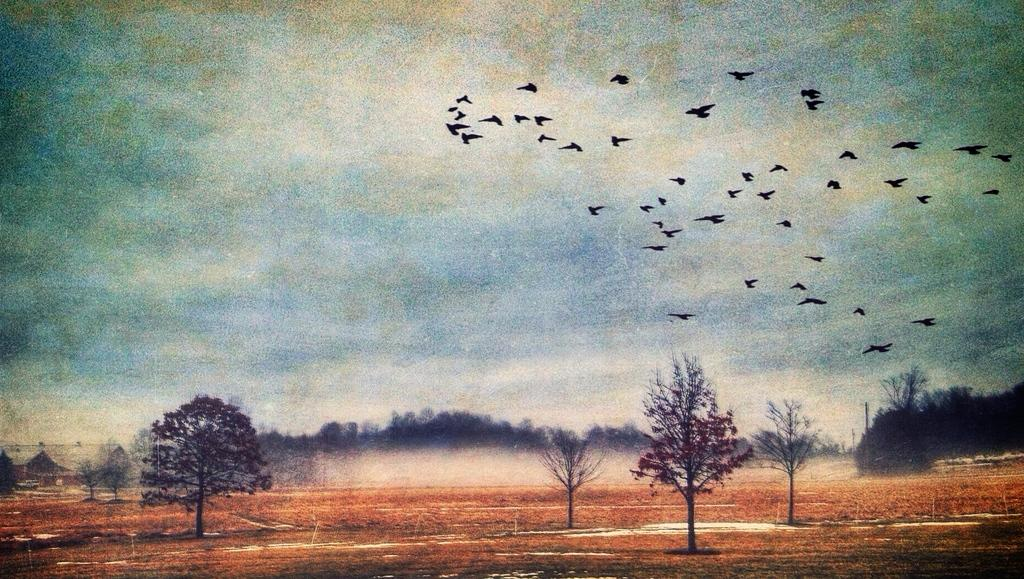What type of vegetation can be seen in the image? There are trees in the image. What animals are present in the image? There are birds in the image. What is visible in the background of the image? The sky is visible in the background of the image, and clouds are present. What type of ground cover is at the bottom of the image? Dry grass is at the bottom of the image. Where is the tub located in the image? There is no tub present in the image. What type of shade is provided by the trees in the image? The image does not show any specific shade provided by the trees; it only shows the trees themselves. 